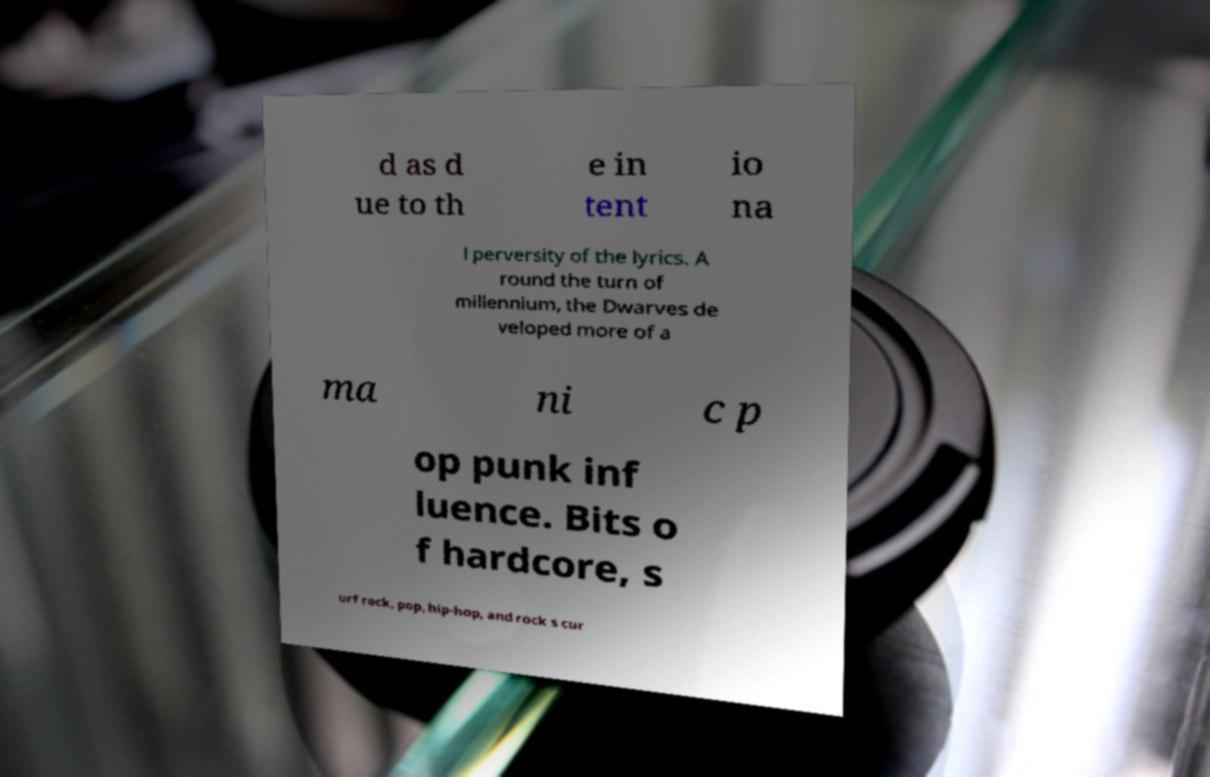Can you accurately transcribe the text from the provided image for me? d as d ue to th e in tent io na l perversity of the lyrics. A round the turn of millennium, the Dwarves de veloped more of a ma ni c p op punk inf luence. Bits o f hardcore, s urf rock, pop, hip-hop, and rock s cur 